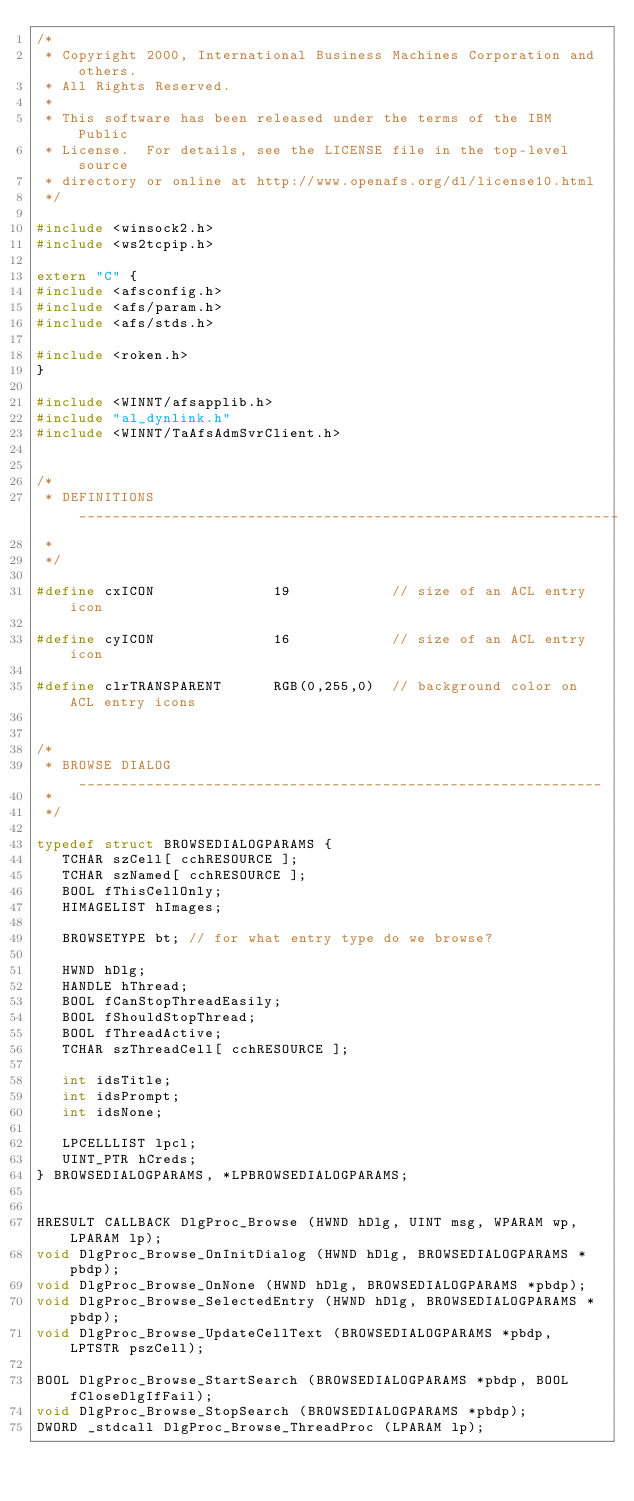Convert code to text. <code><loc_0><loc_0><loc_500><loc_500><_C++_>/*
 * Copyright 2000, International Business Machines Corporation and others.
 * All Rights Reserved.
 *
 * This software has been released under the terms of the IBM Public
 * License.  For details, see the LICENSE file in the top-level source
 * directory or online at http://www.openafs.org/dl/license10.html
 */

#include <winsock2.h>
#include <ws2tcpip.h>

extern "C" {
#include <afsconfig.h>
#include <afs/param.h>
#include <afs/stds.h>

#include <roken.h>
}

#include <WINNT/afsapplib.h>
#include "al_dynlink.h"
#include <WINNT/TaAfsAdmSvrClient.h>


/*
 * DEFINITIONS ________________________________________________________________
 *
 */

#define cxICON              19            // size of an ACL entry icon

#define cyICON              16            // size of an ACL entry icon

#define clrTRANSPARENT      RGB(0,255,0)  // background color on ACL entry icons


/*
 * BROWSE DIALOG ______________________________________________________________
 *
 */

typedef struct BROWSEDIALOGPARAMS {
   TCHAR szCell[ cchRESOURCE ];
   TCHAR szNamed[ cchRESOURCE ];
   BOOL fThisCellOnly;
   HIMAGELIST hImages;

   BROWSETYPE bt;	// for what entry type do we browse?

   HWND hDlg;
   HANDLE hThread;
   BOOL fCanStopThreadEasily;
   BOOL fShouldStopThread;
   BOOL fThreadActive;
   TCHAR szThreadCell[ cchRESOURCE ];

   int idsTitle;
   int idsPrompt;
   int idsNone;

   LPCELLLIST lpcl;
   UINT_PTR hCreds;
} BROWSEDIALOGPARAMS, *LPBROWSEDIALOGPARAMS;


HRESULT CALLBACK DlgProc_Browse (HWND hDlg, UINT msg, WPARAM wp, LPARAM lp);
void DlgProc_Browse_OnInitDialog (HWND hDlg, BROWSEDIALOGPARAMS *pbdp);
void DlgProc_Browse_OnNone (HWND hDlg, BROWSEDIALOGPARAMS *pbdp);
void DlgProc_Browse_SelectedEntry (HWND hDlg, BROWSEDIALOGPARAMS *pbdp);
void DlgProc_Browse_UpdateCellText (BROWSEDIALOGPARAMS *pbdp, LPTSTR pszCell);

BOOL DlgProc_Browse_StartSearch (BROWSEDIALOGPARAMS *pbdp, BOOL fCloseDlgIfFail);
void DlgProc_Browse_StopSearch (BROWSEDIALOGPARAMS *pbdp);
DWORD _stdcall DlgProc_Browse_ThreadProc (LPARAM lp);
</code> 